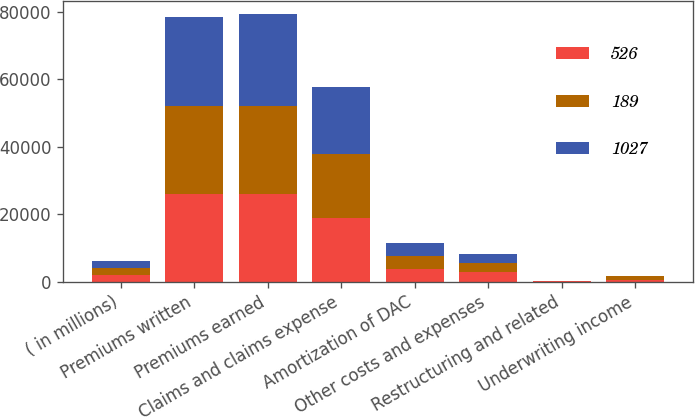<chart> <loc_0><loc_0><loc_500><loc_500><stacked_bar_chart><ecel><fcel>( in millions)<fcel>Premiums written<fcel>Premiums earned<fcel>Claims and claims expense<fcel>Amortization of DAC<fcel>Other costs and expenses<fcel>Restructuring and related<fcel>Underwriting income<nl><fcel>526<fcel>2010<fcel>25906<fcel>25955<fcel>18923<fcel>3678<fcel>2795<fcel>33<fcel>526<nl><fcel>189<fcel>2009<fcel>25972<fcel>26195<fcel>18722<fcel>3789<fcel>2552<fcel>105<fcel>1027<nl><fcel>1027<fcel>2008<fcel>26584<fcel>26967<fcel>20046<fcel>3975<fcel>2735<fcel>22<fcel>189<nl></chart> 